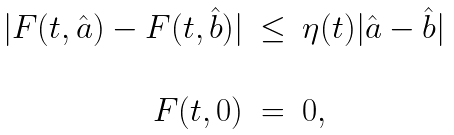<formula> <loc_0><loc_0><loc_500><loc_500>\begin{array} { r c l } | F ( t , \hat { a } ) - F ( t , \hat { b } ) | & \leq & \eta ( t ) | \hat { a } - \hat { b } | \\ \\ F ( t , 0 ) & = & 0 , \\ \end{array}</formula> 